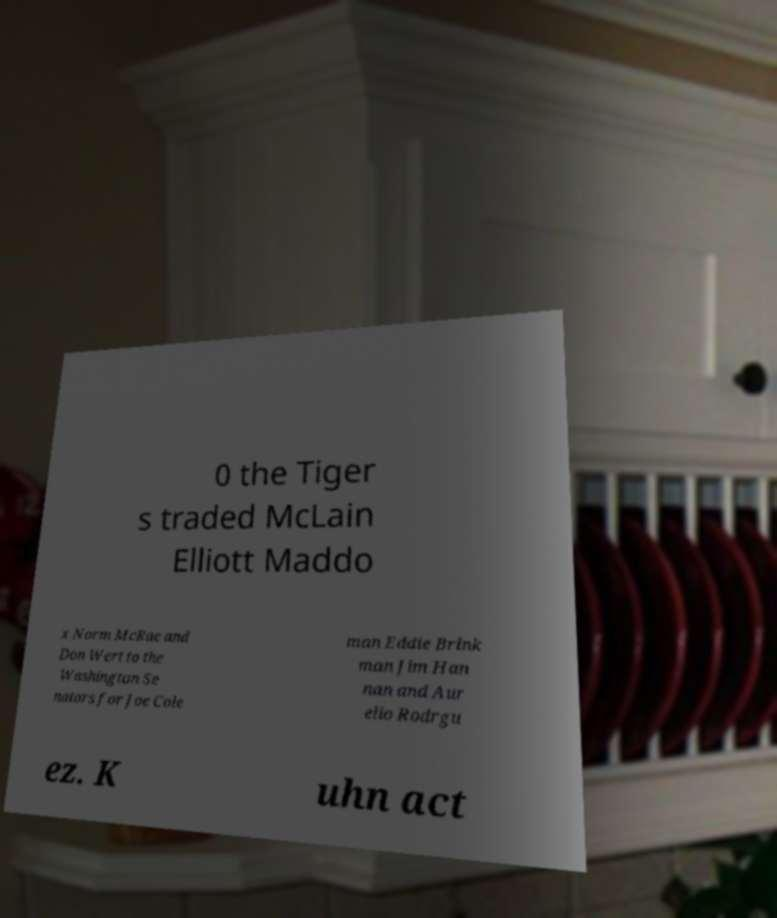Please identify and transcribe the text found in this image. 0 the Tiger s traded McLain Elliott Maddo x Norm McRae and Don Wert to the Washington Se nators for Joe Cole man Eddie Brink man Jim Han nan and Aur elio Rodrgu ez. K uhn act 